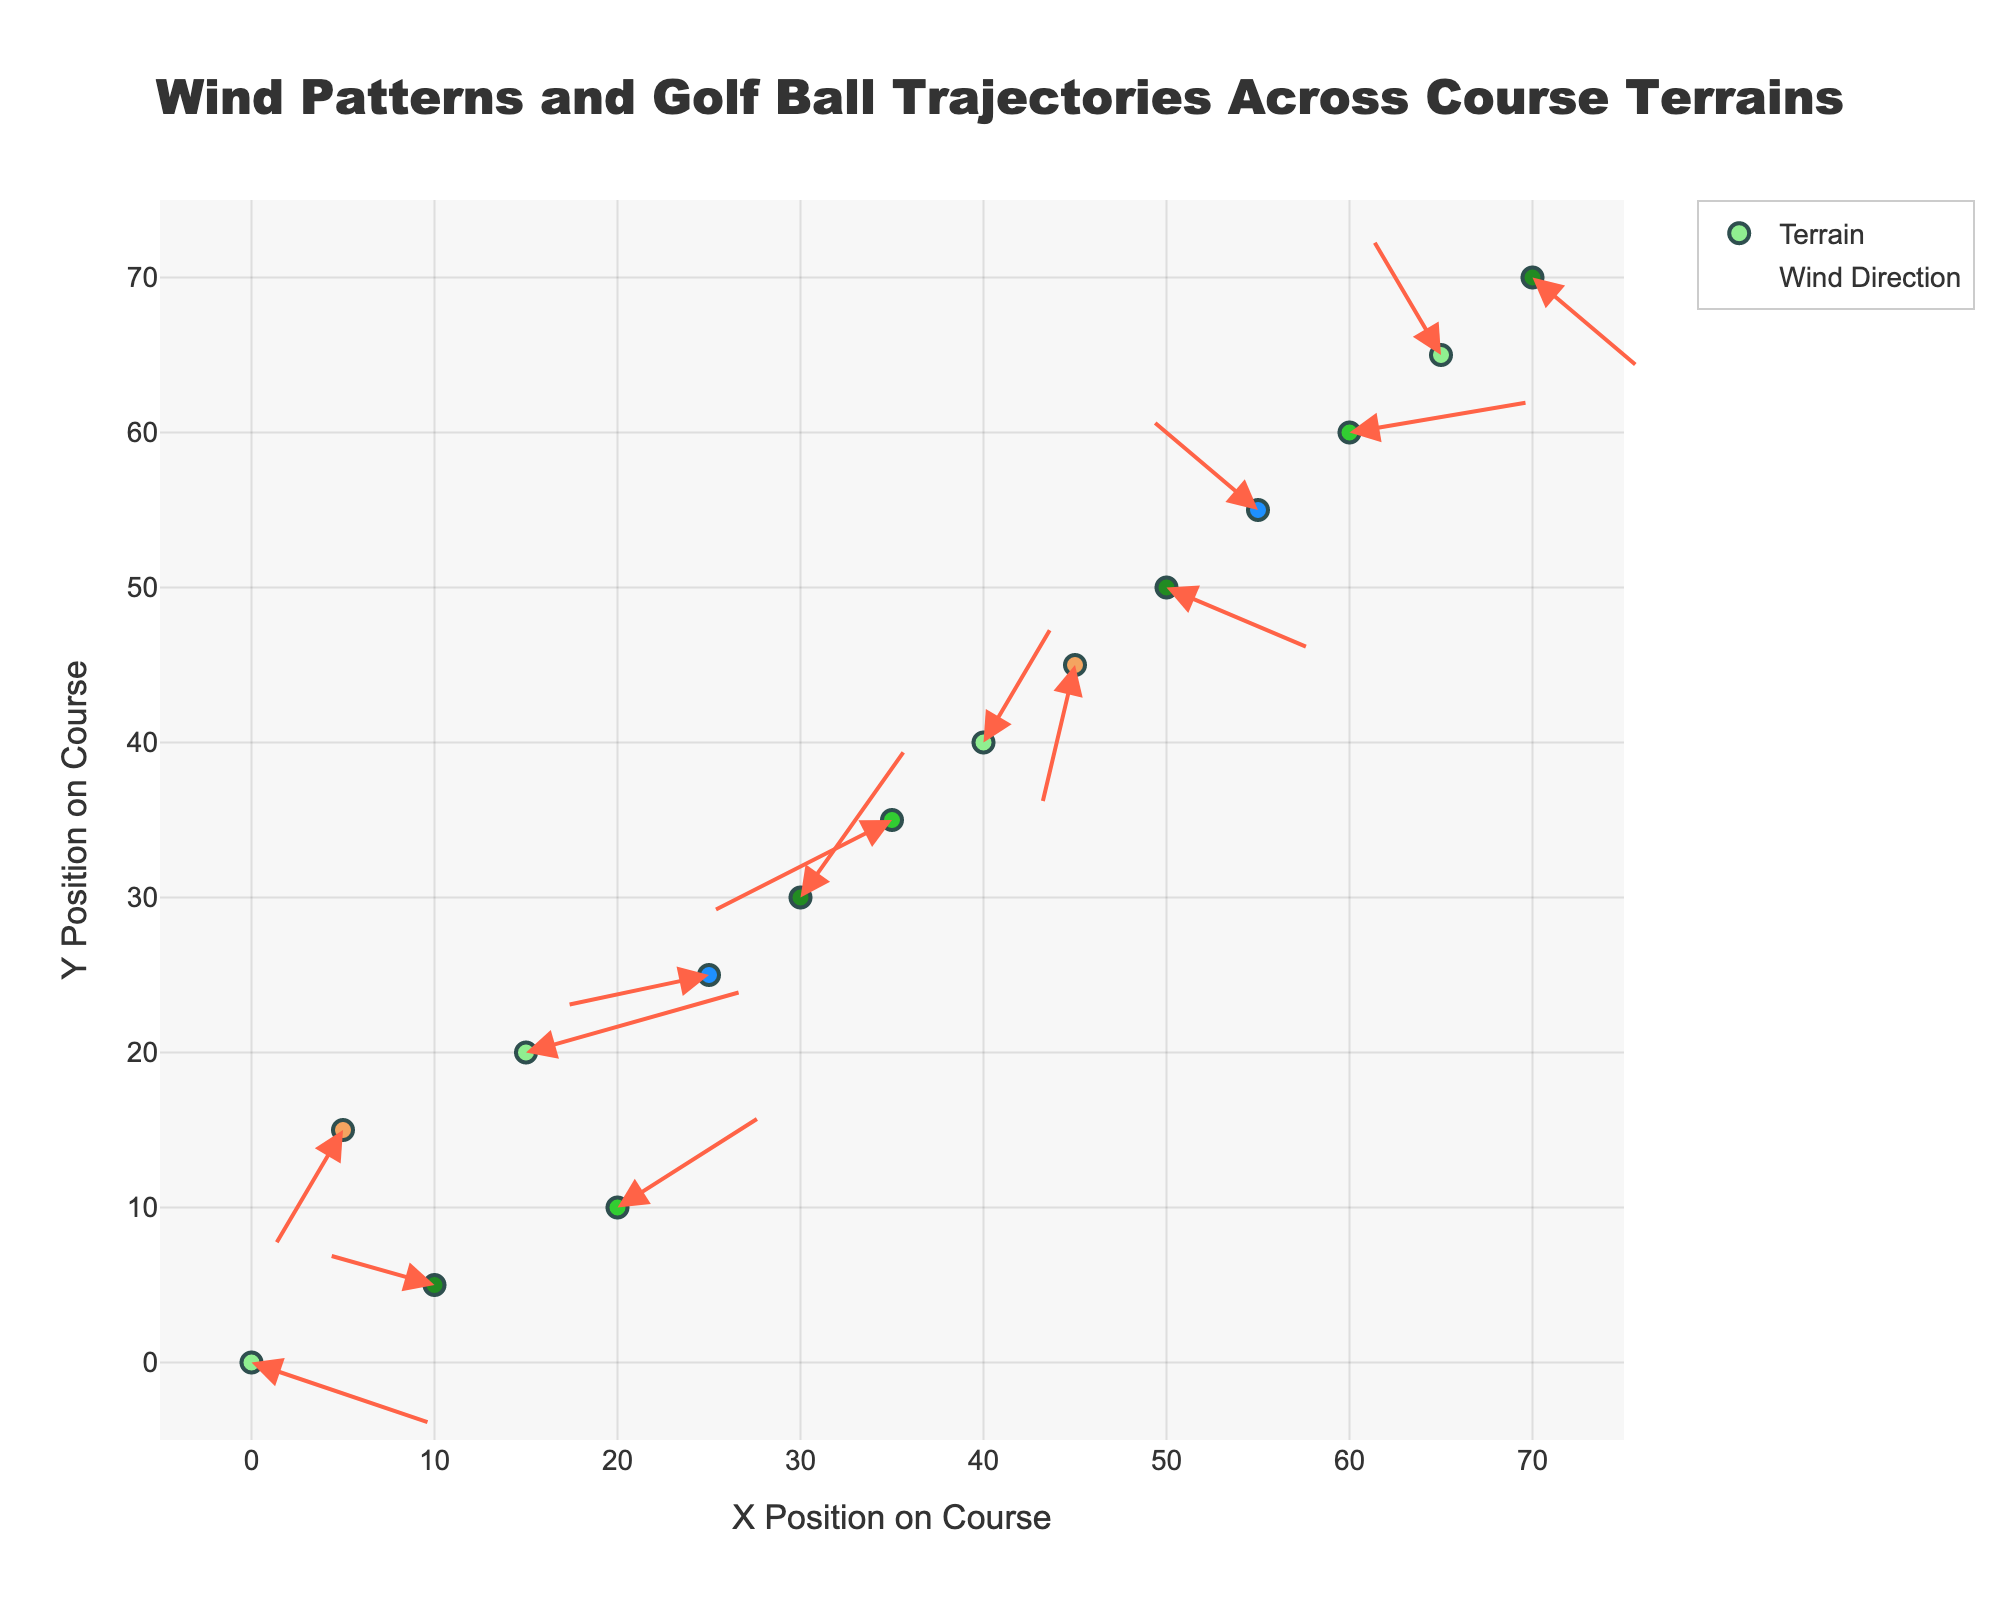What is the title of the plot? The title is located at the top center of the plot, surrounded by a box. By looking at that area, you can read the text mentioned.
Answer: Wind Patterns and Golf Ball Trajectories Across Course Terrains What color represents the "Fairway" terrain? The color associated with the terrain is depicted in the markers. By examining the legend on the right side of the plot, it shows the color and the corresponding terrain.
Answer: Light green How many points have a "Bunker" terrain? Identify the markers that are colored according to the "Bunker" terrain and count them. You can cross-reference this with the text labels that appear on hover or in the legend.
Answer: 2 What is the arrow direction and length indication? Arrows start from each marker and point towards the direction of the wind, scaled appropriately. By looking at the ax and ay coordinates, you can deduce this information.
Answer: Wind direction, scaled arrows What is the x-coordinate of the rough terrain that has an x-component of -3 in wind vector? Scan through markers colored for "Rough" and look for the hover labels or annotations that match the wind vector.
Answer: 10 Which terrain has the highest positive u-component in the wind vector? Identify all wind vectors u-component, then look for the highest positive value and note the corresponding terrain in the hover labels.
Answer: Fairway What is the average y-coordinate of points on the “Green” terrain? Isolate all y-coordinates for the "Green" terrain markers, sum them up, and divide by their count. The Green terrain markers are found by their color or hover labels. (10 + 60 + 35) / 3 = 35
Answer: 35 Which terrain has the strongest negative v-component of the wind vector? Identify the largest negative v values and cross-reference with corresponding terrains from hover labels.
Answer: Bunker How many terrains lie in the quadrant where both x and y coordinates are above 30? Count markers where both x and y coordinates are greater than 30 by examining the upper right section of the plot.
Answer: 5 Which terrain shows a wind vector that moves diagonally upwards to the right? Look for arrows that move rightward and upward from the points, indicating positive u and v components. Then determine the corresponding terrain.
Answer: Rough 